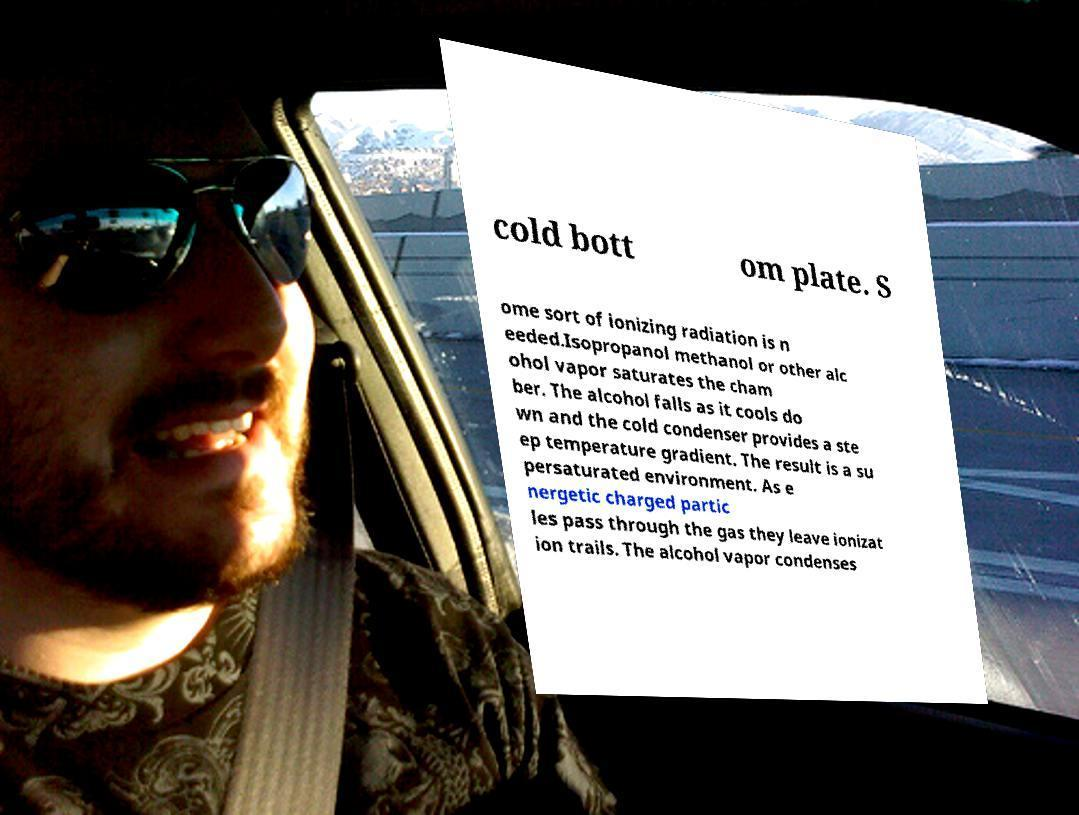Can you accurately transcribe the text from the provided image for me? cold bott om plate. S ome sort of ionizing radiation is n eeded.Isopropanol methanol or other alc ohol vapor saturates the cham ber. The alcohol falls as it cools do wn and the cold condenser provides a ste ep temperature gradient. The result is a su persaturated environment. As e nergetic charged partic les pass through the gas they leave ionizat ion trails. The alcohol vapor condenses 